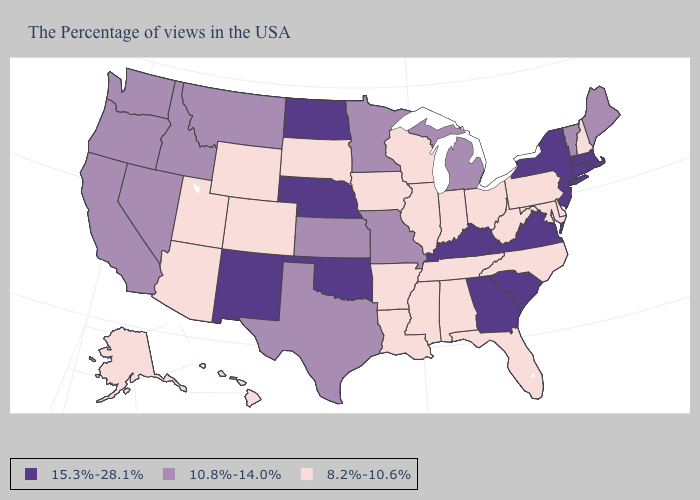Does Connecticut have the highest value in the USA?
Give a very brief answer. Yes. What is the lowest value in states that border Connecticut?
Answer briefly. 15.3%-28.1%. Name the states that have a value in the range 8.2%-10.6%?
Be succinct. New Hampshire, Delaware, Maryland, Pennsylvania, North Carolina, West Virginia, Ohio, Florida, Indiana, Alabama, Tennessee, Wisconsin, Illinois, Mississippi, Louisiana, Arkansas, Iowa, South Dakota, Wyoming, Colorado, Utah, Arizona, Alaska, Hawaii. Name the states that have a value in the range 10.8%-14.0%?
Quick response, please. Maine, Vermont, Michigan, Missouri, Minnesota, Kansas, Texas, Montana, Idaho, Nevada, California, Washington, Oregon. Among the states that border Illinois , which have the lowest value?
Answer briefly. Indiana, Wisconsin, Iowa. What is the value of Florida?
Answer briefly. 8.2%-10.6%. What is the value of Montana?
Keep it brief. 10.8%-14.0%. Among the states that border Illinois , does Kentucky have the highest value?
Quick response, please. Yes. What is the lowest value in states that border Minnesota?
Be succinct. 8.2%-10.6%. What is the value of New Mexico?
Keep it brief. 15.3%-28.1%. What is the highest value in the Northeast ?
Quick response, please. 15.3%-28.1%. Name the states that have a value in the range 10.8%-14.0%?
Concise answer only. Maine, Vermont, Michigan, Missouri, Minnesota, Kansas, Texas, Montana, Idaho, Nevada, California, Washington, Oregon. Name the states that have a value in the range 10.8%-14.0%?
Quick response, please. Maine, Vermont, Michigan, Missouri, Minnesota, Kansas, Texas, Montana, Idaho, Nevada, California, Washington, Oregon. Does New Mexico have the highest value in the USA?
Quick response, please. Yes. Name the states that have a value in the range 10.8%-14.0%?
Keep it brief. Maine, Vermont, Michigan, Missouri, Minnesota, Kansas, Texas, Montana, Idaho, Nevada, California, Washington, Oregon. 